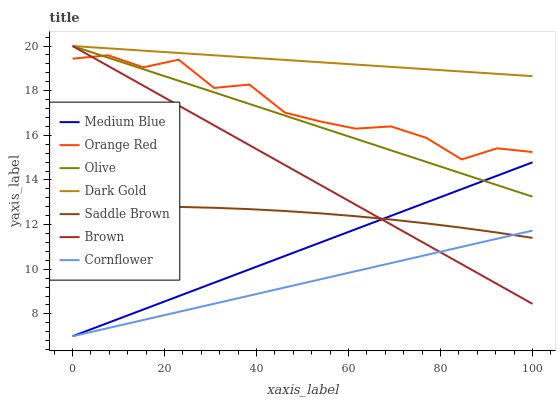Does Cornflower have the minimum area under the curve?
Answer yes or no. Yes. Does Dark Gold have the maximum area under the curve?
Answer yes or no. Yes. Does Medium Blue have the minimum area under the curve?
Answer yes or no. No. Does Medium Blue have the maximum area under the curve?
Answer yes or no. No. Is Olive the smoothest?
Answer yes or no. Yes. Is Orange Red the roughest?
Answer yes or no. Yes. Is Dark Gold the smoothest?
Answer yes or no. No. Is Dark Gold the roughest?
Answer yes or no. No. Does Medium Blue have the lowest value?
Answer yes or no. Yes. Does Dark Gold have the lowest value?
Answer yes or no. No. Does Olive have the highest value?
Answer yes or no. Yes. Does Medium Blue have the highest value?
Answer yes or no. No. Is Saddle Brown less than Dark Gold?
Answer yes or no. Yes. Is Dark Gold greater than Saddle Brown?
Answer yes or no. Yes. Does Olive intersect Orange Red?
Answer yes or no. Yes. Is Olive less than Orange Red?
Answer yes or no. No. Is Olive greater than Orange Red?
Answer yes or no. No. Does Saddle Brown intersect Dark Gold?
Answer yes or no. No. 